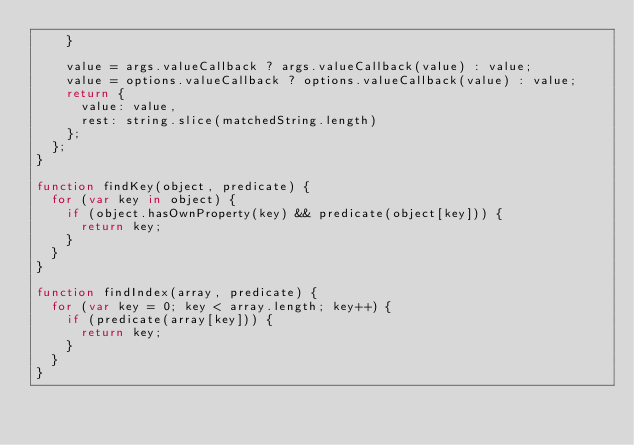<code> <loc_0><loc_0><loc_500><loc_500><_JavaScript_>    }

    value = args.valueCallback ? args.valueCallback(value) : value;
    value = options.valueCallback ? options.valueCallback(value) : value;
    return {
      value: value,
      rest: string.slice(matchedString.length)
    };
  };
}

function findKey(object, predicate) {
  for (var key in object) {
    if (object.hasOwnProperty(key) && predicate(object[key])) {
      return key;
    }
  }
}

function findIndex(array, predicate) {
  for (var key = 0; key < array.length; key++) {
    if (predicate(array[key])) {
      return key;
    }
  }
}</code> 